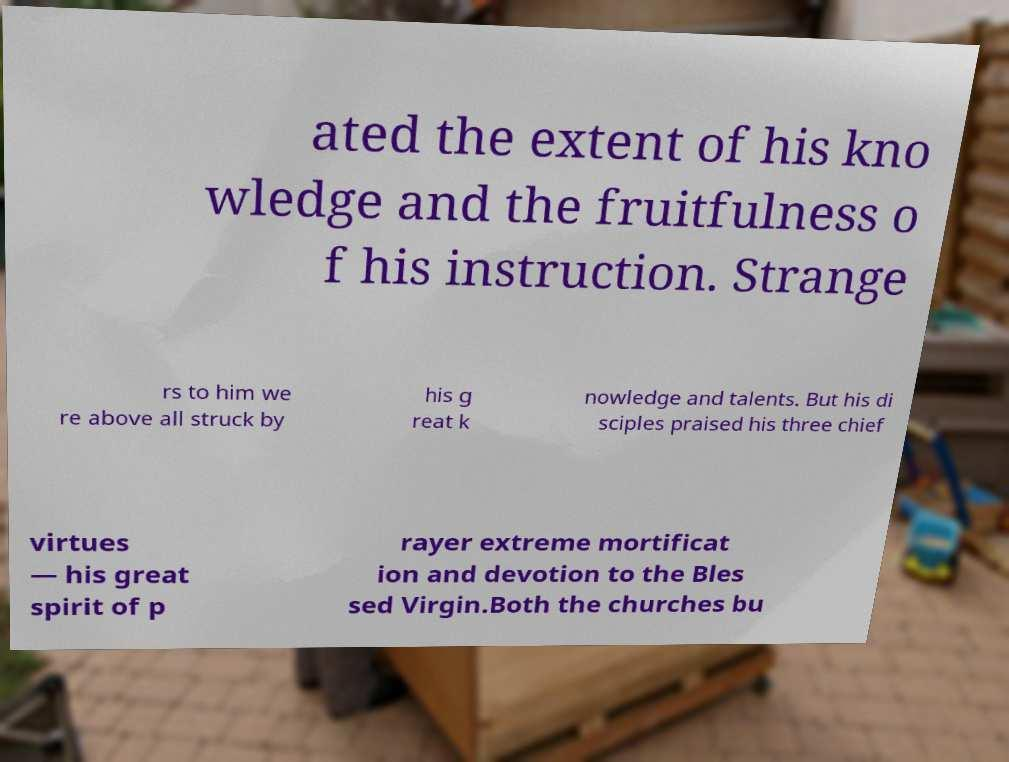Please read and relay the text visible in this image. What does it say? ated the extent of his kno wledge and the fruitfulness o f his instruction. Strange rs to him we re above all struck by his g reat k nowledge and talents. But his di sciples praised his three chief virtues — his great spirit of p rayer extreme mortificat ion and devotion to the Bles sed Virgin.Both the churches bu 